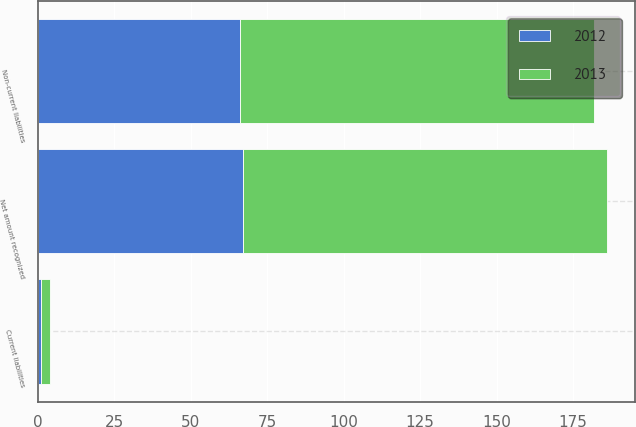Convert chart. <chart><loc_0><loc_0><loc_500><loc_500><stacked_bar_chart><ecel><fcel>Current liabilities<fcel>Non-current liabilities<fcel>Net amount recognized<nl><fcel>2012<fcel>1<fcel>66<fcel>67<nl><fcel>2013<fcel>3<fcel>116<fcel>119<nl></chart> 